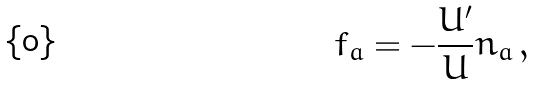Convert formula to latex. <formula><loc_0><loc_0><loc_500><loc_500>f _ { a } = - \frac { U ^ { \prime } } { U } n _ { a } \, ,</formula> 